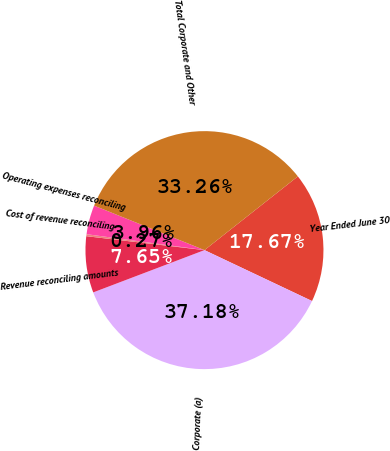Convert chart. <chart><loc_0><loc_0><loc_500><loc_500><pie_chart><fcel>Year Ended June 30<fcel>Corporate (a)<fcel>Revenue reconciling amounts<fcel>Cost of revenue reconciling<fcel>Operating expenses reconciling<fcel>Total Corporate and Other<nl><fcel>17.67%<fcel>37.18%<fcel>7.65%<fcel>0.27%<fcel>3.96%<fcel>33.26%<nl></chart> 